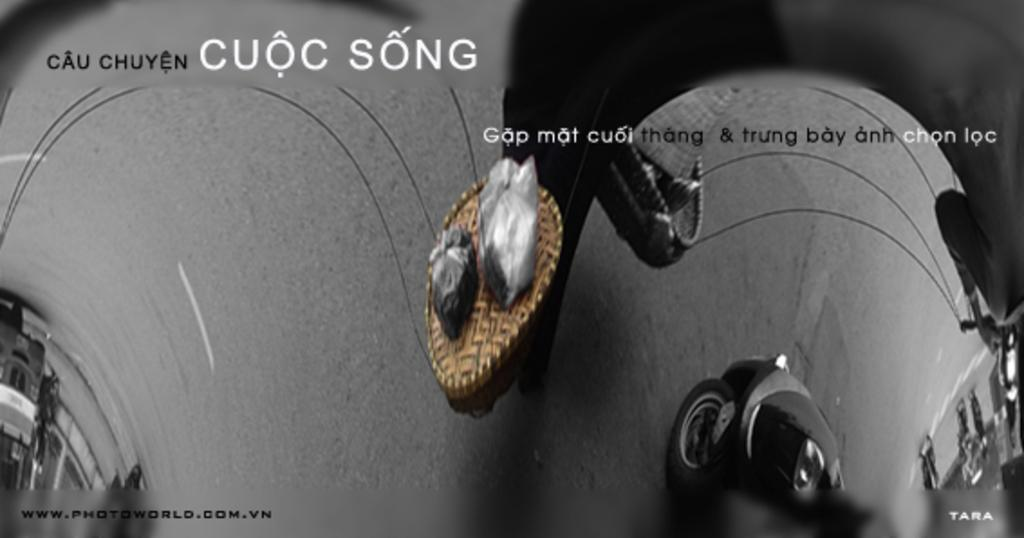What is the main feature of the image? There is a road in the image. What object can be seen near the road? There is a wooden box with two covers in the image. What is happening on the right side of the road? A vehicle is moving on the right side of the road. What structure is located on the left side of the image? There is a building on the left side of the image. What type of instrument is being played in the image? There is no instrument being played in the image. What stage of development can be observed in the image? The image does not depict any developmental stages; it shows a road, a wooden box, a moving vehicle, and a building. 